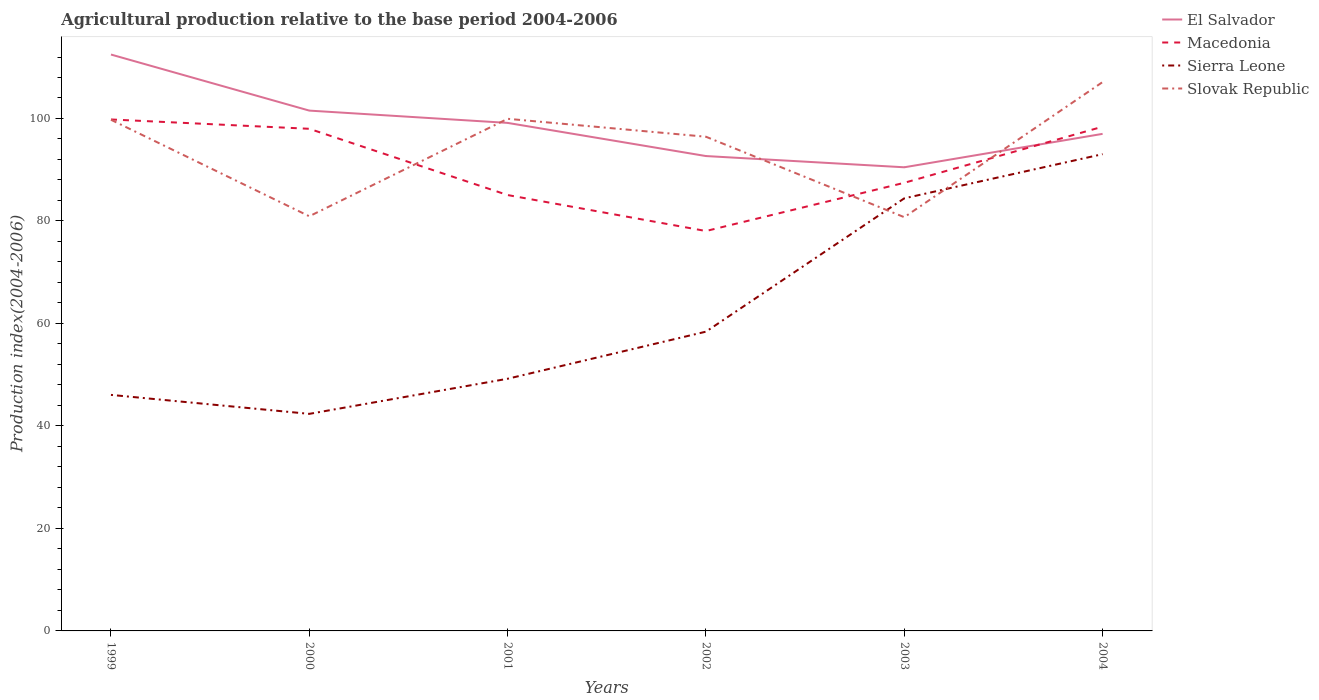Across all years, what is the maximum agricultural production index in El Salvador?
Provide a succinct answer. 90.48. In which year was the agricultural production index in El Salvador maximum?
Your answer should be very brief. 2003. What is the total agricultural production index in El Salvador in the graph?
Provide a succinct answer. 10.94. What is the difference between the highest and the second highest agricultural production index in Slovak Republic?
Offer a very short reply. 26.37. Is the agricultural production index in Slovak Republic strictly greater than the agricultural production index in Macedonia over the years?
Provide a short and direct response. No. What is the difference between two consecutive major ticks on the Y-axis?
Provide a succinct answer. 20. Are the values on the major ticks of Y-axis written in scientific E-notation?
Your answer should be very brief. No. Does the graph contain any zero values?
Give a very brief answer. No. Does the graph contain grids?
Offer a terse response. No. How are the legend labels stacked?
Offer a terse response. Vertical. What is the title of the graph?
Ensure brevity in your answer.  Agricultural production relative to the base period 2004-2006. Does "Colombia" appear as one of the legend labels in the graph?
Offer a very short reply. No. What is the label or title of the Y-axis?
Make the answer very short. Production index(2004-2006). What is the Production index(2004-2006) of El Salvador in 1999?
Give a very brief answer. 112.48. What is the Production index(2004-2006) of Macedonia in 1999?
Your response must be concise. 99.81. What is the Production index(2004-2006) of Sierra Leone in 1999?
Your response must be concise. 46.06. What is the Production index(2004-2006) in Slovak Republic in 1999?
Your answer should be very brief. 99.75. What is the Production index(2004-2006) in El Salvador in 2000?
Keep it short and to the point. 101.54. What is the Production index(2004-2006) in Macedonia in 2000?
Make the answer very short. 97.99. What is the Production index(2004-2006) in Sierra Leone in 2000?
Provide a succinct answer. 42.36. What is the Production index(2004-2006) in Slovak Republic in 2000?
Keep it short and to the point. 80.92. What is the Production index(2004-2006) of El Salvador in 2001?
Your answer should be compact. 99.14. What is the Production index(2004-2006) of Macedonia in 2001?
Provide a succinct answer. 85.06. What is the Production index(2004-2006) of Sierra Leone in 2001?
Provide a succinct answer. 49.21. What is the Production index(2004-2006) of Slovak Republic in 2001?
Offer a terse response. 99.94. What is the Production index(2004-2006) in El Salvador in 2002?
Your answer should be compact. 92.67. What is the Production index(2004-2006) in Macedonia in 2002?
Provide a succinct answer. 78.04. What is the Production index(2004-2006) of Sierra Leone in 2002?
Your response must be concise. 58.4. What is the Production index(2004-2006) of Slovak Republic in 2002?
Your answer should be very brief. 96.44. What is the Production index(2004-2006) in El Salvador in 2003?
Your response must be concise. 90.48. What is the Production index(2004-2006) in Macedonia in 2003?
Your answer should be very brief. 87.45. What is the Production index(2004-2006) of Sierra Leone in 2003?
Offer a terse response. 84.42. What is the Production index(2004-2006) in Slovak Republic in 2003?
Keep it short and to the point. 80.74. What is the Production index(2004-2006) of El Salvador in 2004?
Your answer should be compact. 97. What is the Production index(2004-2006) of Macedonia in 2004?
Make the answer very short. 98.4. What is the Production index(2004-2006) of Sierra Leone in 2004?
Your answer should be very brief. 93.04. What is the Production index(2004-2006) of Slovak Republic in 2004?
Your answer should be compact. 107.11. Across all years, what is the maximum Production index(2004-2006) of El Salvador?
Ensure brevity in your answer.  112.48. Across all years, what is the maximum Production index(2004-2006) in Macedonia?
Make the answer very short. 99.81. Across all years, what is the maximum Production index(2004-2006) of Sierra Leone?
Ensure brevity in your answer.  93.04. Across all years, what is the maximum Production index(2004-2006) in Slovak Republic?
Ensure brevity in your answer.  107.11. Across all years, what is the minimum Production index(2004-2006) in El Salvador?
Provide a succinct answer. 90.48. Across all years, what is the minimum Production index(2004-2006) of Macedonia?
Keep it short and to the point. 78.04. Across all years, what is the minimum Production index(2004-2006) in Sierra Leone?
Your response must be concise. 42.36. Across all years, what is the minimum Production index(2004-2006) of Slovak Republic?
Your answer should be compact. 80.74. What is the total Production index(2004-2006) of El Salvador in the graph?
Give a very brief answer. 593.31. What is the total Production index(2004-2006) of Macedonia in the graph?
Offer a terse response. 546.75. What is the total Production index(2004-2006) in Sierra Leone in the graph?
Your response must be concise. 373.49. What is the total Production index(2004-2006) in Slovak Republic in the graph?
Provide a succinct answer. 564.9. What is the difference between the Production index(2004-2006) of El Salvador in 1999 and that in 2000?
Offer a very short reply. 10.94. What is the difference between the Production index(2004-2006) in Macedonia in 1999 and that in 2000?
Your response must be concise. 1.82. What is the difference between the Production index(2004-2006) of Sierra Leone in 1999 and that in 2000?
Your response must be concise. 3.7. What is the difference between the Production index(2004-2006) of Slovak Republic in 1999 and that in 2000?
Your answer should be compact. 18.83. What is the difference between the Production index(2004-2006) in El Salvador in 1999 and that in 2001?
Ensure brevity in your answer.  13.34. What is the difference between the Production index(2004-2006) of Macedonia in 1999 and that in 2001?
Offer a very short reply. 14.75. What is the difference between the Production index(2004-2006) in Sierra Leone in 1999 and that in 2001?
Provide a short and direct response. -3.15. What is the difference between the Production index(2004-2006) in Slovak Republic in 1999 and that in 2001?
Your answer should be compact. -0.19. What is the difference between the Production index(2004-2006) of El Salvador in 1999 and that in 2002?
Make the answer very short. 19.81. What is the difference between the Production index(2004-2006) of Macedonia in 1999 and that in 2002?
Offer a terse response. 21.77. What is the difference between the Production index(2004-2006) in Sierra Leone in 1999 and that in 2002?
Your response must be concise. -12.34. What is the difference between the Production index(2004-2006) of Slovak Republic in 1999 and that in 2002?
Provide a succinct answer. 3.31. What is the difference between the Production index(2004-2006) of Macedonia in 1999 and that in 2003?
Offer a terse response. 12.36. What is the difference between the Production index(2004-2006) in Sierra Leone in 1999 and that in 2003?
Provide a short and direct response. -38.36. What is the difference between the Production index(2004-2006) of Slovak Republic in 1999 and that in 2003?
Your response must be concise. 19.01. What is the difference between the Production index(2004-2006) of El Salvador in 1999 and that in 2004?
Your answer should be very brief. 15.48. What is the difference between the Production index(2004-2006) of Macedonia in 1999 and that in 2004?
Provide a short and direct response. 1.41. What is the difference between the Production index(2004-2006) in Sierra Leone in 1999 and that in 2004?
Offer a terse response. -46.98. What is the difference between the Production index(2004-2006) in Slovak Republic in 1999 and that in 2004?
Keep it short and to the point. -7.36. What is the difference between the Production index(2004-2006) in Macedonia in 2000 and that in 2001?
Provide a succinct answer. 12.93. What is the difference between the Production index(2004-2006) in Sierra Leone in 2000 and that in 2001?
Offer a terse response. -6.85. What is the difference between the Production index(2004-2006) in Slovak Republic in 2000 and that in 2001?
Ensure brevity in your answer.  -19.02. What is the difference between the Production index(2004-2006) in El Salvador in 2000 and that in 2002?
Provide a succinct answer. 8.87. What is the difference between the Production index(2004-2006) of Macedonia in 2000 and that in 2002?
Make the answer very short. 19.95. What is the difference between the Production index(2004-2006) of Sierra Leone in 2000 and that in 2002?
Provide a short and direct response. -16.04. What is the difference between the Production index(2004-2006) of Slovak Republic in 2000 and that in 2002?
Offer a terse response. -15.52. What is the difference between the Production index(2004-2006) in El Salvador in 2000 and that in 2003?
Your answer should be very brief. 11.06. What is the difference between the Production index(2004-2006) of Macedonia in 2000 and that in 2003?
Offer a terse response. 10.54. What is the difference between the Production index(2004-2006) in Sierra Leone in 2000 and that in 2003?
Your answer should be very brief. -42.06. What is the difference between the Production index(2004-2006) of Slovak Republic in 2000 and that in 2003?
Make the answer very short. 0.18. What is the difference between the Production index(2004-2006) in El Salvador in 2000 and that in 2004?
Give a very brief answer. 4.54. What is the difference between the Production index(2004-2006) in Macedonia in 2000 and that in 2004?
Your answer should be very brief. -0.41. What is the difference between the Production index(2004-2006) in Sierra Leone in 2000 and that in 2004?
Ensure brevity in your answer.  -50.68. What is the difference between the Production index(2004-2006) of Slovak Republic in 2000 and that in 2004?
Your answer should be very brief. -26.19. What is the difference between the Production index(2004-2006) in El Salvador in 2001 and that in 2002?
Your answer should be very brief. 6.47. What is the difference between the Production index(2004-2006) in Macedonia in 2001 and that in 2002?
Your response must be concise. 7.02. What is the difference between the Production index(2004-2006) of Sierra Leone in 2001 and that in 2002?
Your answer should be very brief. -9.19. What is the difference between the Production index(2004-2006) of El Salvador in 2001 and that in 2003?
Give a very brief answer. 8.66. What is the difference between the Production index(2004-2006) in Macedonia in 2001 and that in 2003?
Your answer should be very brief. -2.39. What is the difference between the Production index(2004-2006) in Sierra Leone in 2001 and that in 2003?
Offer a terse response. -35.21. What is the difference between the Production index(2004-2006) of Slovak Republic in 2001 and that in 2003?
Keep it short and to the point. 19.2. What is the difference between the Production index(2004-2006) in El Salvador in 2001 and that in 2004?
Your answer should be very brief. 2.14. What is the difference between the Production index(2004-2006) of Macedonia in 2001 and that in 2004?
Make the answer very short. -13.34. What is the difference between the Production index(2004-2006) in Sierra Leone in 2001 and that in 2004?
Make the answer very short. -43.83. What is the difference between the Production index(2004-2006) in Slovak Republic in 2001 and that in 2004?
Your response must be concise. -7.17. What is the difference between the Production index(2004-2006) of El Salvador in 2002 and that in 2003?
Provide a short and direct response. 2.19. What is the difference between the Production index(2004-2006) in Macedonia in 2002 and that in 2003?
Provide a succinct answer. -9.41. What is the difference between the Production index(2004-2006) in Sierra Leone in 2002 and that in 2003?
Your answer should be very brief. -26.02. What is the difference between the Production index(2004-2006) of El Salvador in 2002 and that in 2004?
Keep it short and to the point. -4.33. What is the difference between the Production index(2004-2006) of Macedonia in 2002 and that in 2004?
Offer a very short reply. -20.36. What is the difference between the Production index(2004-2006) of Sierra Leone in 2002 and that in 2004?
Offer a terse response. -34.64. What is the difference between the Production index(2004-2006) in Slovak Republic in 2002 and that in 2004?
Your response must be concise. -10.67. What is the difference between the Production index(2004-2006) in El Salvador in 2003 and that in 2004?
Offer a very short reply. -6.52. What is the difference between the Production index(2004-2006) of Macedonia in 2003 and that in 2004?
Offer a very short reply. -10.95. What is the difference between the Production index(2004-2006) of Sierra Leone in 2003 and that in 2004?
Your answer should be very brief. -8.62. What is the difference between the Production index(2004-2006) in Slovak Republic in 2003 and that in 2004?
Your response must be concise. -26.37. What is the difference between the Production index(2004-2006) in El Salvador in 1999 and the Production index(2004-2006) in Macedonia in 2000?
Provide a short and direct response. 14.49. What is the difference between the Production index(2004-2006) of El Salvador in 1999 and the Production index(2004-2006) of Sierra Leone in 2000?
Provide a short and direct response. 70.12. What is the difference between the Production index(2004-2006) of El Salvador in 1999 and the Production index(2004-2006) of Slovak Republic in 2000?
Offer a terse response. 31.56. What is the difference between the Production index(2004-2006) of Macedonia in 1999 and the Production index(2004-2006) of Sierra Leone in 2000?
Give a very brief answer. 57.45. What is the difference between the Production index(2004-2006) of Macedonia in 1999 and the Production index(2004-2006) of Slovak Republic in 2000?
Your answer should be compact. 18.89. What is the difference between the Production index(2004-2006) of Sierra Leone in 1999 and the Production index(2004-2006) of Slovak Republic in 2000?
Provide a short and direct response. -34.86. What is the difference between the Production index(2004-2006) in El Salvador in 1999 and the Production index(2004-2006) in Macedonia in 2001?
Offer a very short reply. 27.42. What is the difference between the Production index(2004-2006) in El Salvador in 1999 and the Production index(2004-2006) in Sierra Leone in 2001?
Make the answer very short. 63.27. What is the difference between the Production index(2004-2006) of El Salvador in 1999 and the Production index(2004-2006) of Slovak Republic in 2001?
Offer a terse response. 12.54. What is the difference between the Production index(2004-2006) in Macedonia in 1999 and the Production index(2004-2006) in Sierra Leone in 2001?
Keep it short and to the point. 50.6. What is the difference between the Production index(2004-2006) in Macedonia in 1999 and the Production index(2004-2006) in Slovak Republic in 2001?
Make the answer very short. -0.13. What is the difference between the Production index(2004-2006) of Sierra Leone in 1999 and the Production index(2004-2006) of Slovak Republic in 2001?
Keep it short and to the point. -53.88. What is the difference between the Production index(2004-2006) in El Salvador in 1999 and the Production index(2004-2006) in Macedonia in 2002?
Provide a short and direct response. 34.44. What is the difference between the Production index(2004-2006) in El Salvador in 1999 and the Production index(2004-2006) in Sierra Leone in 2002?
Ensure brevity in your answer.  54.08. What is the difference between the Production index(2004-2006) in El Salvador in 1999 and the Production index(2004-2006) in Slovak Republic in 2002?
Make the answer very short. 16.04. What is the difference between the Production index(2004-2006) in Macedonia in 1999 and the Production index(2004-2006) in Sierra Leone in 2002?
Ensure brevity in your answer.  41.41. What is the difference between the Production index(2004-2006) in Macedonia in 1999 and the Production index(2004-2006) in Slovak Republic in 2002?
Give a very brief answer. 3.37. What is the difference between the Production index(2004-2006) of Sierra Leone in 1999 and the Production index(2004-2006) of Slovak Republic in 2002?
Your answer should be very brief. -50.38. What is the difference between the Production index(2004-2006) in El Salvador in 1999 and the Production index(2004-2006) in Macedonia in 2003?
Offer a very short reply. 25.03. What is the difference between the Production index(2004-2006) of El Salvador in 1999 and the Production index(2004-2006) of Sierra Leone in 2003?
Provide a short and direct response. 28.06. What is the difference between the Production index(2004-2006) of El Salvador in 1999 and the Production index(2004-2006) of Slovak Republic in 2003?
Ensure brevity in your answer.  31.74. What is the difference between the Production index(2004-2006) of Macedonia in 1999 and the Production index(2004-2006) of Sierra Leone in 2003?
Offer a very short reply. 15.39. What is the difference between the Production index(2004-2006) in Macedonia in 1999 and the Production index(2004-2006) in Slovak Republic in 2003?
Your response must be concise. 19.07. What is the difference between the Production index(2004-2006) in Sierra Leone in 1999 and the Production index(2004-2006) in Slovak Republic in 2003?
Provide a short and direct response. -34.68. What is the difference between the Production index(2004-2006) of El Salvador in 1999 and the Production index(2004-2006) of Macedonia in 2004?
Ensure brevity in your answer.  14.08. What is the difference between the Production index(2004-2006) in El Salvador in 1999 and the Production index(2004-2006) in Sierra Leone in 2004?
Provide a succinct answer. 19.44. What is the difference between the Production index(2004-2006) of El Salvador in 1999 and the Production index(2004-2006) of Slovak Republic in 2004?
Make the answer very short. 5.37. What is the difference between the Production index(2004-2006) of Macedonia in 1999 and the Production index(2004-2006) of Sierra Leone in 2004?
Give a very brief answer. 6.77. What is the difference between the Production index(2004-2006) of Sierra Leone in 1999 and the Production index(2004-2006) of Slovak Republic in 2004?
Ensure brevity in your answer.  -61.05. What is the difference between the Production index(2004-2006) in El Salvador in 2000 and the Production index(2004-2006) in Macedonia in 2001?
Offer a very short reply. 16.48. What is the difference between the Production index(2004-2006) in El Salvador in 2000 and the Production index(2004-2006) in Sierra Leone in 2001?
Provide a succinct answer. 52.33. What is the difference between the Production index(2004-2006) of El Salvador in 2000 and the Production index(2004-2006) of Slovak Republic in 2001?
Offer a very short reply. 1.6. What is the difference between the Production index(2004-2006) in Macedonia in 2000 and the Production index(2004-2006) in Sierra Leone in 2001?
Offer a very short reply. 48.78. What is the difference between the Production index(2004-2006) of Macedonia in 2000 and the Production index(2004-2006) of Slovak Republic in 2001?
Ensure brevity in your answer.  -1.95. What is the difference between the Production index(2004-2006) in Sierra Leone in 2000 and the Production index(2004-2006) in Slovak Republic in 2001?
Make the answer very short. -57.58. What is the difference between the Production index(2004-2006) of El Salvador in 2000 and the Production index(2004-2006) of Macedonia in 2002?
Give a very brief answer. 23.5. What is the difference between the Production index(2004-2006) in El Salvador in 2000 and the Production index(2004-2006) in Sierra Leone in 2002?
Keep it short and to the point. 43.14. What is the difference between the Production index(2004-2006) in El Salvador in 2000 and the Production index(2004-2006) in Slovak Republic in 2002?
Your response must be concise. 5.1. What is the difference between the Production index(2004-2006) of Macedonia in 2000 and the Production index(2004-2006) of Sierra Leone in 2002?
Give a very brief answer. 39.59. What is the difference between the Production index(2004-2006) of Macedonia in 2000 and the Production index(2004-2006) of Slovak Republic in 2002?
Offer a terse response. 1.55. What is the difference between the Production index(2004-2006) in Sierra Leone in 2000 and the Production index(2004-2006) in Slovak Republic in 2002?
Your answer should be very brief. -54.08. What is the difference between the Production index(2004-2006) of El Salvador in 2000 and the Production index(2004-2006) of Macedonia in 2003?
Your answer should be compact. 14.09. What is the difference between the Production index(2004-2006) of El Salvador in 2000 and the Production index(2004-2006) of Sierra Leone in 2003?
Ensure brevity in your answer.  17.12. What is the difference between the Production index(2004-2006) of El Salvador in 2000 and the Production index(2004-2006) of Slovak Republic in 2003?
Provide a succinct answer. 20.8. What is the difference between the Production index(2004-2006) of Macedonia in 2000 and the Production index(2004-2006) of Sierra Leone in 2003?
Your response must be concise. 13.57. What is the difference between the Production index(2004-2006) of Macedonia in 2000 and the Production index(2004-2006) of Slovak Republic in 2003?
Your answer should be compact. 17.25. What is the difference between the Production index(2004-2006) in Sierra Leone in 2000 and the Production index(2004-2006) in Slovak Republic in 2003?
Ensure brevity in your answer.  -38.38. What is the difference between the Production index(2004-2006) of El Salvador in 2000 and the Production index(2004-2006) of Macedonia in 2004?
Keep it short and to the point. 3.14. What is the difference between the Production index(2004-2006) in El Salvador in 2000 and the Production index(2004-2006) in Slovak Republic in 2004?
Your answer should be compact. -5.57. What is the difference between the Production index(2004-2006) in Macedonia in 2000 and the Production index(2004-2006) in Sierra Leone in 2004?
Keep it short and to the point. 4.95. What is the difference between the Production index(2004-2006) in Macedonia in 2000 and the Production index(2004-2006) in Slovak Republic in 2004?
Your response must be concise. -9.12. What is the difference between the Production index(2004-2006) in Sierra Leone in 2000 and the Production index(2004-2006) in Slovak Republic in 2004?
Provide a short and direct response. -64.75. What is the difference between the Production index(2004-2006) in El Salvador in 2001 and the Production index(2004-2006) in Macedonia in 2002?
Make the answer very short. 21.1. What is the difference between the Production index(2004-2006) in El Salvador in 2001 and the Production index(2004-2006) in Sierra Leone in 2002?
Offer a terse response. 40.74. What is the difference between the Production index(2004-2006) of Macedonia in 2001 and the Production index(2004-2006) of Sierra Leone in 2002?
Your answer should be compact. 26.66. What is the difference between the Production index(2004-2006) of Macedonia in 2001 and the Production index(2004-2006) of Slovak Republic in 2002?
Offer a terse response. -11.38. What is the difference between the Production index(2004-2006) in Sierra Leone in 2001 and the Production index(2004-2006) in Slovak Republic in 2002?
Offer a very short reply. -47.23. What is the difference between the Production index(2004-2006) of El Salvador in 2001 and the Production index(2004-2006) of Macedonia in 2003?
Keep it short and to the point. 11.69. What is the difference between the Production index(2004-2006) of El Salvador in 2001 and the Production index(2004-2006) of Sierra Leone in 2003?
Your answer should be compact. 14.72. What is the difference between the Production index(2004-2006) of Macedonia in 2001 and the Production index(2004-2006) of Sierra Leone in 2003?
Give a very brief answer. 0.64. What is the difference between the Production index(2004-2006) in Macedonia in 2001 and the Production index(2004-2006) in Slovak Republic in 2003?
Your answer should be very brief. 4.32. What is the difference between the Production index(2004-2006) in Sierra Leone in 2001 and the Production index(2004-2006) in Slovak Republic in 2003?
Your answer should be compact. -31.53. What is the difference between the Production index(2004-2006) of El Salvador in 2001 and the Production index(2004-2006) of Macedonia in 2004?
Offer a very short reply. 0.74. What is the difference between the Production index(2004-2006) of El Salvador in 2001 and the Production index(2004-2006) of Sierra Leone in 2004?
Provide a succinct answer. 6.1. What is the difference between the Production index(2004-2006) of El Salvador in 2001 and the Production index(2004-2006) of Slovak Republic in 2004?
Offer a very short reply. -7.97. What is the difference between the Production index(2004-2006) of Macedonia in 2001 and the Production index(2004-2006) of Sierra Leone in 2004?
Keep it short and to the point. -7.98. What is the difference between the Production index(2004-2006) in Macedonia in 2001 and the Production index(2004-2006) in Slovak Republic in 2004?
Your response must be concise. -22.05. What is the difference between the Production index(2004-2006) of Sierra Leone in 2001 and the Production index(2004-2006) of Slovak Republic in 2004?
Provide a succinct answer. -57.9. What is the difference between the Production index(2004-2006) in El Salvador in 2002 and the Production index(2004-2006) in Macedonia in 2003?
Offer a very short reply. 5.22. What is the difference between the Production index(2004-2006) in El Salvador in 2002 and the Production index(2004-2006) in Sierra Leone in 2003?
Your response must be concise. 8.25. What is the difference between the Production index(2004-2006) in El Salvador in 2002 and the Production index(2004-2006) in Slovak Republic in 2003?
Your answer should be very brief. 11.93. What is the difference between the Production index(2004-2006) of Macedonia in 2002 and the Production index(2004-2006) of Sierra Leone in 2003?
Ensure brevity in your answer.  -6.38. What is the difference between the Production index(2004-2006) in Macedonia in 2002 and the Production index(2004-2006) in Slovak Republic in 2003?
Give a very brief answer. -2.7. What is the difference between the Production index(2004-2006) in Sierra Leone in 2002 and the Production index(2004-2006) in Slovak Republic in 2003?
Keep it short and to the point. -22.34. What is the difference between the Production index(2004-2006) of El Salvador in 2002 and the Production index(2004-2006) of Macedonia in 2004?
Your response must be concise. -5.73. What is the difference between the Production index(2004-2006) of El Salvador in 2002 and the Production index(2004-2006) of Sierra Leone in 2004?
Your response must be concise. -0.37. What is the difference between the Production index(2004-2006) in El Salvador in 2002 and the Production index(2004-2006) in Slovak Republic in 2004?
Offer a terse response. -14.44. What is the difference between the Production index(2004-2006) in Macedonia in 2002 and the Production index(2004-2006) in Slovak Republic in 2004?
Offer a very short reply. -29.07. What is the difference between the Production index(2004-2006) of Sierra Leone in 2002 and the Production index(2004-2006) of Slovak Republic in 2004?
Your response must be concise. -48.71. What is the difference between the Production index(2004-2006) of El Salvador in 2003 and the Production index(2004-2006) of Macedonia in 2004?
Make the answer very short. -7.92. What is the difference between the Production index(2004-2006) in El Salvador in 2003 and the Production index(2004-2006) in Sierra Leone in 2004?
Your response must be concise. -2.56. What is the difference between the Production index(2004-2006) of El Salvador in 2003 and the Production index(2004-2006) of Slovak Republic in 2004?
Ensure brevity in your answer.  -16.63. What is the difference between the Production index(2004-2006) in Macedonia in 2003 and the Production index(2004-2006) in Sierra Leone in 2004?
Give a very brief answer. -5.59. What is the difference between the Production index(2004-2006) of Macedonia in 2003 and the Production index(2004-2006) of Slovak Republic in 2004?
Give a very brief answer. -19.66. What is the difference between the Production index(2004-2006) of Sierra Leone in 2003 and the Production index(2004-2006) of Slovak Republic in 2004?
Provide a short and direct response. -22.69. What is the average Production index(2004-2006) in El Salvador per year?
Provide a short and direct response. 98.89. What is the average Production index(2004-2006) of Macedonia per year?
Your answer should be compact. 91.12. What is the average Production index(2004-2006) in Sierra Leone per year?
Provide a succinct answer. 62.25. What is the average Production index(2004-2006) of Slovak Republic per year?
Provide a succinct answer. 94.15. In the year 1999, what is the difference between the Production index(2004-2006) of El Salvador and Production index(2004-2006) of Macedonia?
Offer a terse response. 12.67. In the year 1999, what is the difference between the Production index(2004-2006) of El Salvador and Production index(2004-2006) of Sierra Leone?
Provide a succinct answer. 66.42. In the year 1999, what is the difference between the Production index(2004-2006) in El Salvador and Production index(2004-2006) in Slovak Republic?
Ensure brevity in your answer.  12.73. In the year 1999, what is the difference between the Production index(2004-2006) in Macedonia and Production index(2004-2006) in Sierra Leone?
Keep it short and to the point. 53.75. In the year 1999, what is the difference between the Production index(2004-2006) of Macedonia and Production index(2004-2006) of Slovak Republic?
Ensure brevity in your answer.  0.06. In the year 1999, what is the difference between the Production index(2004-2006) in Sierra Leone and Production index(2004-2006) in Slovak Republic?
Provide a succinct answer. -53.69. In the year 2000, what is the difference between the Production index(2004-2006) in El Salvador and Production index(2004-2006) in Macedonia?
Your response must be concise. 3.55. In the year 2000, what is the difference between the Production index(2004-2006) in El Salvador and Production index(2004-2006) in Sierra Leone?
Keep it short and to the point. 59.18. In the year 2000, what is the difference between the Production index(2004-2006) of El Salvador and Production index(2004-2006) of Slovak Republic?
Offer a very short reply. 20.62. In the year 2000, what is the difference between the Production index(2004-2006) in Macedonia and Production index(2004-2006) in Sierra Leone?
Provide a short and direct response. 55.63. In the year 2000, what is the difference between the Production index(2004-2006) in Macedonia and Production index(2004-2006) in Slovak Republic?
Offer a terse response. 17.07. In the year 2000, what is the difference between the Production index(2004-2006) in Sierra Leone and Production index(2004-2006) in Slovak Republic?
Keep it short and to the point. -38.56. In the year 2001, what is the difference between the Production index(2004-2006) of El Salvador and Production index(2004-2006) of Macedonia?
Give a very brief answer. 14.08. In the year 2001, what is the difference between the Production index(2004-2006) of El Salvador and Production index(2004-2006) of Sierra Leone?
Provide a succinct answer. 49.93. In the year 2001, what is the difference between the Production index(2004-2006) in El Salvador and Production index(2004-2006) in Slovak Republic?
Give a very brief answer. -0.8. In the year 2001, what is the difference between the Production index(2004-2006) of Macedonia and Production index(2004-2006) of Sierra Leone?
Your response must be concise. 35.85. In the year 2001, what is the difference between the Production index(2004-2006) in Macedonia and Production index(2004-2006) in Slovak Republic?
Make the answer very short. -14.88. In the year 2001, what is the difference between the Production index(2004-2006) in Sierra Leone and Production index(2004-2006) in Slovak Republic?
Offer a terse response. -50.73. In the year 2002, what is the difference between the Production index(2004-2006) of El Salvador and Production index(2004-2006) of Macedonia?
Your answer should be very brief. 14.63. In the year 2002, what is the difference between the Production index(2004-2006) in El Salvador and Production index(2004-2006) in Sierra Leone?
Provide a succinct answer. 34.27. In the year 2002, what is the difference between the Production index(2004-2006) in El Salvador and Production index(2004-2006) in Slovak Republic?
Ensure brevity in your answer.  -3.77. In the year 2002, what is the difference between the Production index(2004-2006) in Macedonia and Production index(2004-2006) in Sierra Leone?
Keep it short and to the point. 19.64. In the year 2002, what is the difference between the Production index(2004-2006) in Macedonia and Production index(2004-2006) in Slovak Republic?
Keep it short and to the point. -18.4. In the year 2002, what is the difference between the Production index(2004-2006) of Sierra Leone and Production index(2004-2006) of Slovak Republic?
Provide a short and direct response. -38.04. In the year 2003, what is the difference between the Production index(2004-2006) in El Salvador and Production index(2004-2006) in Macedonia?
Your answer should be very brief. 3.03. In the year 2003, what is the difference between the Production index(2004-2006) in El Salvador and Production index(2004-2006) in Sierra Leone?
Provide a succinct answer. 6.06. In the year 2003, what is the difference between the Production index(2004-2006) of El Salvador and Production index(2004-2006) of Slovak Republic?
Make the answer very short. 9.74. In the year 2003, what is the difference between the Production index(2004-2006) in Macedonia and Production index(2004-2006) in Sierra Leone?
Provide a succinct answer. 3.03. In the year 2003, what is the difference between the Production index(2004-2006) of Macedonia and Production index(2004-2006) of Slovak Republic?
Make the answer very short. 6.71. In the year 2003, what is the difference between the Production index(2004-2006) of Sierra Leone and Production index(2004-2006) of Slovak Republic?
Provide a succinct answer. 3.68. In the year 2004, what is the difference between the Production index(2004-2006) in El Salvador and Production index(2004-2006) in Sierra Leone?
Provide a short and direct response. 3.96. In the year 2004, what is the difference between the Production index(2004-2006) of El Salvador and Production index(2004-2006) of Slovak Republic?
Offer a very short reply. -10.11. In the year 2004, what is the difference between the Production index(2004-2006) of Macedonia and Production index(2004-2006) of Sierra Leone?
Ensure brevity in your answer.  5.36. In the year 2004, what is the difference between the Production index(2004-2006) of Macedonia and Production index(2004-2006) of Slovak Republic?
Your answer should be very brief. -8.71. In the year 2004, what is the difference between the Production index(2004-2006) of Sierra Leone and Production index(2004-2006) of Slovak Republic?
Your answer should be compact. -14.07. What is the ratio of the Production index(2004-2006) in El Salvador in 1999 to that in 2000?
Your answer should be compact. 1.11. What is the ratio of the Production index(2004-2006) of Macedonia in 1999 to that in 2000?
Make the answer very short. 1.02. What is the ratio of the Production index(2004-2006) in Sierra Leone in 1999 to that in 2000?
Provide a short and direct response. 1.09. What is the ratio of the Production index(2004-2006) in Slovak Republic in 1999 to that in 2000?
Offer a very short reply. 1.23. What is the ratio of the Production index(2004-2006) in El Salvador in 1999 to that in 2001?
Make the answer very short. 1.13. What is the ratio of the Production index(2004-2006) in Macedonia in 1999 to that in 2001?
Ensure brevity in your answer.  1.17. What is the ratio of the Production index(2004-2006) of Sierra Leone in 1999 to that in 2001?
Ensure brevity in your answer.  0.94. What is the ratio of the Production index(2004-2006) of El Salvador in 1999 to that in 2002?
Keep it short and to the point. 1.21. What is the ratio of the Production index(2004-2006) in Macedonia in 1999 to that in 2002?
Make the answer very short. 1.28. What is the ratio of the Production index(2004-2006) of Sierra Leone in 1999 to that in 2002?
Provide a short and direct response. 0.79. What is the ratio of the Production index(2004-2006) of Slovak Republic in 1999 to that in 2002?
Provide a short and direct response. 1.03. What is the ratio of the Production index(2004-2006) of El Salvador in 1999 to that in 2003?
Give a very brief answer. 1.24. What is the ratio of the Production index(2004-2006) in Macedonia in 1999 to that in 2003?
Your response must be concise. 1.14. What is the ratio of the Production index(2004-2006) in Sierra Leone in 1999 to that in 2003?
Your answer should be very brief. 0.55. What is the ratio of the Production index(2004-2006) in Slovak Republic in 1999 to that in 2003?
Ensure brevity in your answer.  1.24. What is the ratio of the Production index(2004-2006) in El Salvador in 1999 to that in 2004?
Give a very brief answer. 1.16. What is the ratio of the Production index(2004-2006) in Macedonia in 1999 to that in 2004?
Provide a succinct answer. 1.01. What is the ratio of the Production index(2004-2006) in Sierra Leone in 1999 to that in 2004?
Give a very brief answer. 0.5. What is the ratio of the Production index(2004-2006) in Slovak Republic in 1999 to that in 2004?
Provide a short and direct response. 0.93. What is the ratio of the Production index(2004-2006) of El Salvador in 2000 to that in 2001?
Offer a very short reply. 1.02. What is the ratio of the Production index(2004-2006) of Macedonia in 2000 to that in 2001?
Make the answer very short. 1.15. What is the ratio of the Production index(2004-2006) in Sierra Leone in 2000 to that in 2001?
Keep it short and to the point. 0.86. What is the ratio of the Production index(2004-2006) in Slovak Republic in 2000 to that in 2001?
Keep it short and to the point. 0.81. What is the ratio of the Production index(2004-2006) of El Salvador in 2000 to that in 2002?
Your answer should be compact. 1.1. What is the ratio of the Production index(2004-2006) in Macedonia in 2000 to that in 2002?
Make the answer very short. 1.26. What is the ratio of the Production index(2004-2006) in Sierra Leone in 2000 to that in 2002?
Offer a terse response. 0.73. What is the ratio of the Production index(2004-2006) in Slovak Republic in 2000 to that in 2002?
Make the answer very short. 0.84. What is the ratio of the Production index(2004-2006) in El Salvador in 2000 to that in 2003?
Offer a terse response. 1.12. What is the ratio of the Production index(2004-2006) of Macedonia in 2000 to that in 2003?
Provide a short and direct response. 1.12. What is the ratio of the Production index(2004-2006) of Sierra Leone in 2000 to that in 2003?
Ensure brevity in your answer.  0.5. What is the ratio of the Production index(2004-2006) of El Salvador in 2000 to that in 2004?
Provide a short and direct response. 1.05. What is the ratio of the Production index(2004-2006) of Sierra Leone in 2000 to that in 2004?
Your answer should be compact. 0.46. What is the ratio of the Production index(2004-2006) in Slovak Republic in 2000 to that in 2004?
Your answer should be very brief. 0.76. What is the ratio of the Production index(2004-2006) of El Salvador in 2001 to that in 2002?
Your response must be concise. 1.07. What is the ratio of the Production index(2004-2006) in Macedonia in 2001 to that in 2002?
Give a very brief answer. 1.09. What is the ratio of the Production index(2004-2006) of Sierra Leone in 2001 to that in 2002?
Keep it short and to the point. 0.84. What is the ratio of the Production index(2004-2006) in Slovak Republic in 2001 to that in 2002?
Provide a short and direct response. 1.04. What is the ratio of the Production index(2004-2006) of El Salvador in 2001 to that in 2003?
Give a very brief answer. 1.1. What is the ratio of the Production index(2004-2006) of Macedonia in 2001 to that in 2003?
Keep it short and to the point. 0.97. What is the ratio of the Production index(2004-2006) in Sierra Leone in 2001 to that in 2003?
Keep it short and to the point. 0.58. What is the ratio of the Production index(2004-2006) of Slovak Republic in 2001 to that in 2003?
Provide a short and direct response. 1.24. What is the ratio of the Production index(2004-2006) of El Salvador in 2001 to that in 2004?
Your answer should be very brief. 1.02. What is the ratio of the Production index(2004-2006) in Macedonia in 2001 to that in 2004?
Keep it short and to the point. 0.86. What is the ratio of the Production index(2004-2006) in Sierra Leone in 2001 to that in 2004?
Give a very brief answer. 0.53. What is the ratio of the Production index(2004-2006) in Slovak Republic in 2001 to that in 2004?
Provide a succinct answer. 0.93. What is the ratio of the Production index(2004-2006) of El Salvador in 2002 to that in 2003?
Make the answer very short. 1.02. What is the ratio of the Production index(2004-2006) in Macedonia in 2002 to that in 2003?
Offer a terse response. 0.89. What is the ratio of the Production index(2004-2006) in Sierra Leone in 2002 to that in 2003?
Provide a succinct answer. 0.69. What is the ratio of the Production index(2004-2006) in Slovak Republic in 2002 to that in 2003?
Provide a short and direct response. 1.19. What is the ratio of the Production index(2004-2006) in El Salvador in 2002 to that in 2004?
Offer a very short reply. 0.96. What is the ratio of the Production index(2004-2006) in Macedonia in 2002 to that in 2004?
Offer a very short reply. 0.79. What is the ratio of the Production index(2004-2006) of Sierra Leone in 2002 to that in 2004?
Provide a succinct answer. 0.63. What is the ratio of the Production index(2004-2006) in Slovak Republic in 2002 to that in 2004?
Your answer should be compact. 0.9. What is the ratio of the Production index(2004-2006) of El Salvador in 2003 to that in 2004?
Your response must be concise. 0.93. What is the ratio of the Production index(2004-2006) in Macedonia in 2003 to that in 2004?
Give a very brief answer. 0.89. What is the ratio of the Production index(2004-2006) of Sierra Leone in 2003 to that in 2004?
Give a very brief answer. 0.91. What is the ratio of the Production index(2004-2006) of Slovak Republic in 2003 to that in 2004?
Your response must be concise. 0.75. What is the difference between the highest and the second highest Production index(2004-2006) of El Salvador?
Offer a very short reply. 10.94. What is the difference between the highest and the second highest Production index(2004-2006) in Macedonia?
Make the answer very short. 1.41. What is the difference between the highest and the second highest Production index(2004-2006) of Sierra Leone?
Offer a terse response. 8.62. What is the difference between the highest and the second highest Production index(2004-2006) of Slovak Republic?
Make the answer very short. 7.17. What is the difference between the highest and the lowest Production index(2004-2006) of Macedonia?
Your response must be concise. 21.77. What is the difference between the highest and the lowest Production index(2004-2006) of Sierra Leone?
Offer a terse response. 50.68. What is the difference between the highest and the lowest Production index(2004-2006) of Slovak Republic?
Offer a terse response. 26.37. 